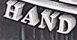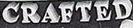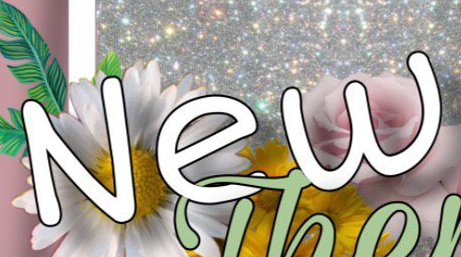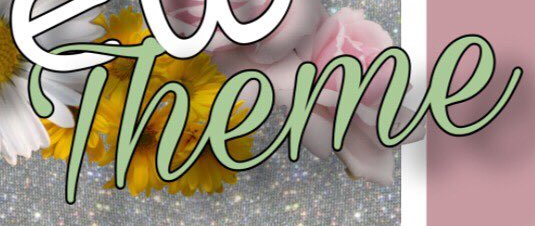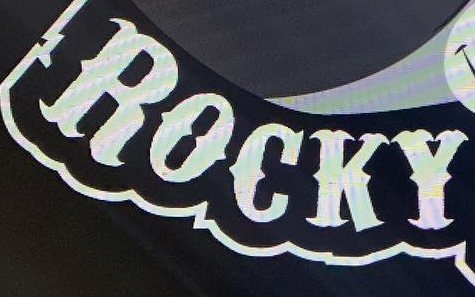What text is displayed in these images sequentially, separated by a semicolon? HAND; CRAFTED; New; Theme; ROCKY 